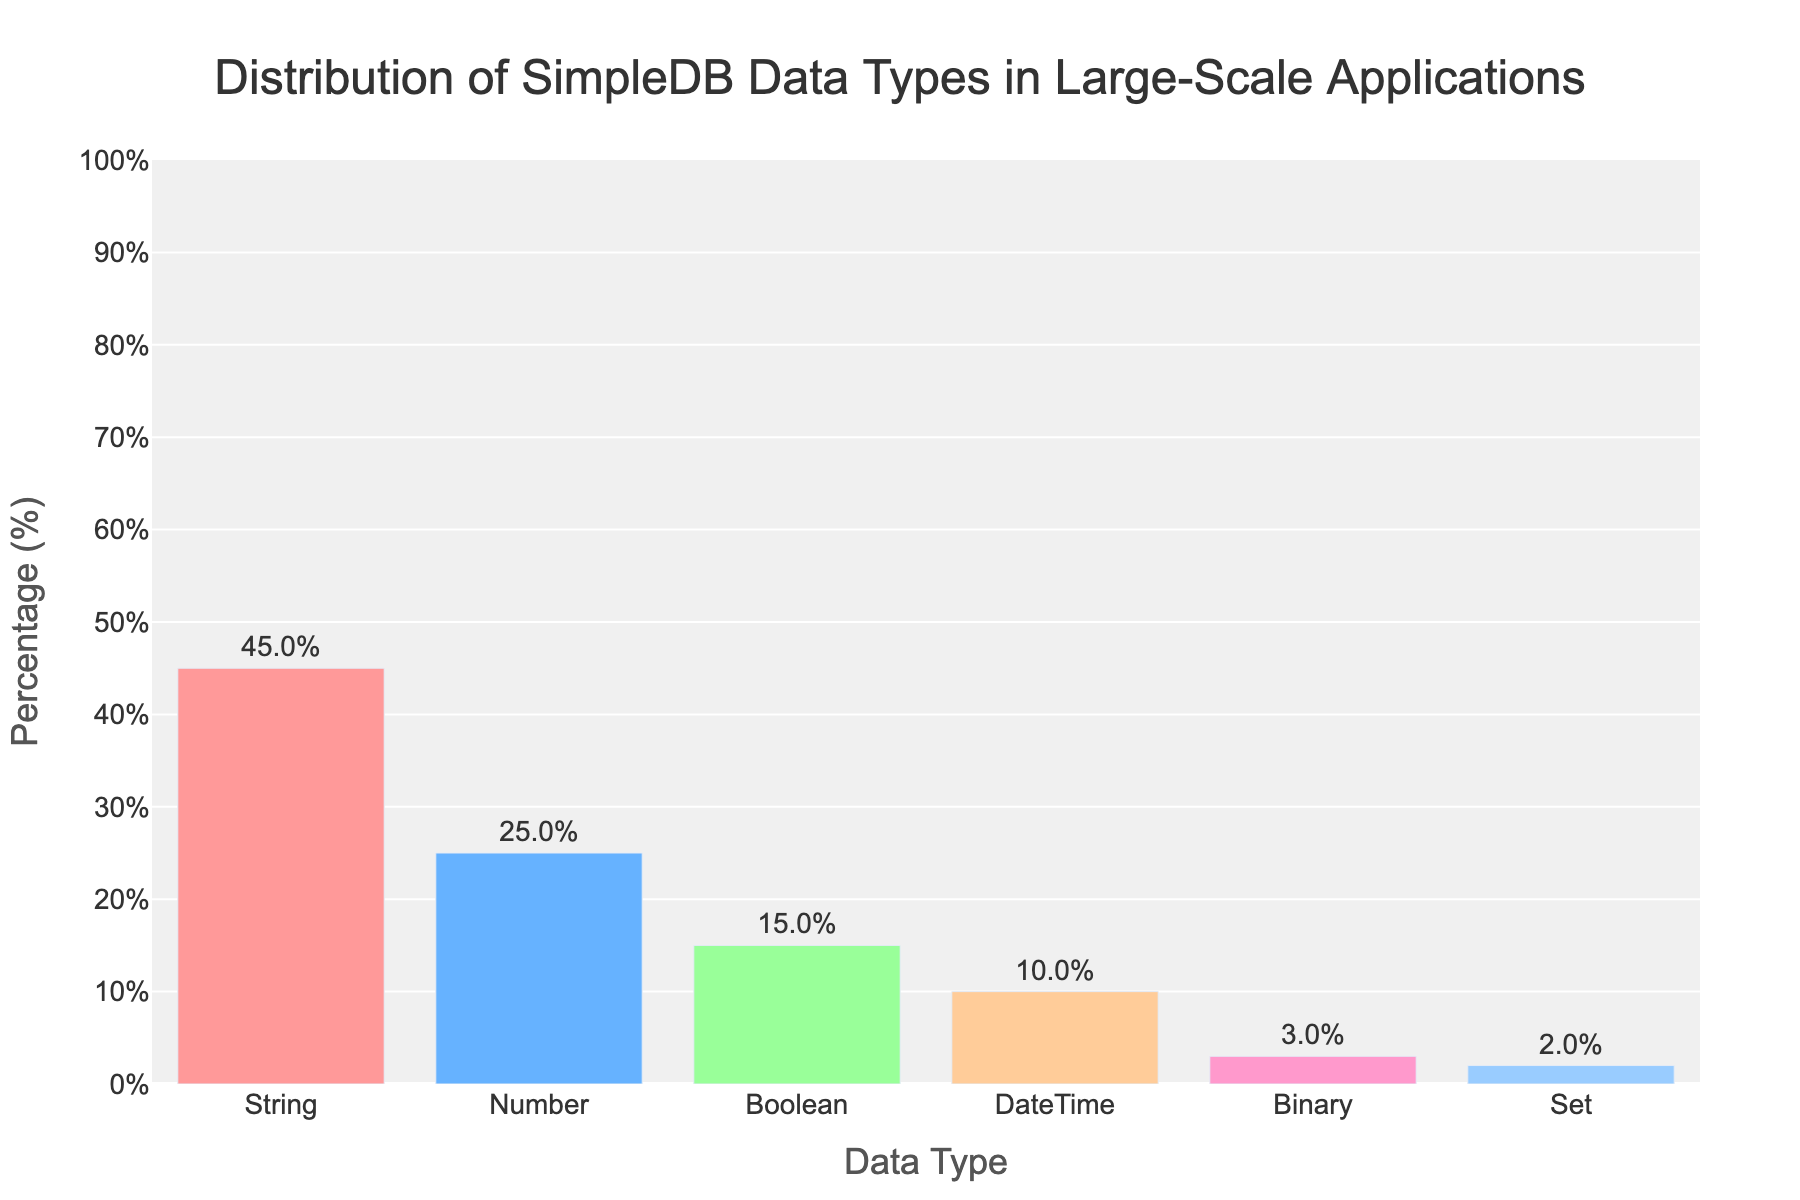Which data type has the highest percentage in the distribution? By observing the bar chart, the data type with the tallest bar represents the largest percentage. The bar associated with "String" is the tallest, showing the highest percentage.
Answer: String How much higher is the percentage of the "Number" data type compared to the "Binary" data type? The heights of the bars indicate the percentages. The "Number" data type has a percentage of 25%, and the "Binary" data type has 3%. The difference is 25% - 3%.
Answer: 22% What is the combined percentage of the "Boolean" and "DateTime" data types? The corresponding bars for "Boolean" and "DateTime" indicate 15% and 10%, respectively. Adding these together gives 15% + 10%.
Answer: 25% Which data type has the smallest percentage, and what is that percentage? The shortest bar in the chart corresponds to the "Set" data type, indicating it has the smallest percentage. The percentage shown is 2%.
Answer: Set, 2% How does the percentage of "String" compare to the total percentage of "Boolean" and "DateTime" combined? The "String" data type has a percentage of 45%, while the sum of "Boolean" (15%) and "DateTime" (10%) is 25%. The "String" percentage is higher by 45% - 25%.
Answer: 20% higher What is the percentage difference between the most and least common data types? The "String" data type represents the highest percentage (45%), and the "Set" data type represents the lowest (2%). The difference is 45% - 2%.
Answer: 43% What fraction of the data types are used less than 10% of the time? The data types with percentages less than 10% are "Binary" (3%) and "Set" (2%). Out of six total data types, there are 2 such data types, so the fraction is 2/6.
Answer: 1/3 What is the total percentage for all data types except "String"? By adding the percentages of "Number" (25%), "Boolean" (15%), "DateTime" (10%), "Binary" (3%), and "Set" (2%), we find the total excluding "String".
Answer: 55% What are the colors used for the bars representing the "Boolean" and "Set" data types? The bar representing "Boolean" is green, and the bar representing "Set" is also a shade of blue. The choice of colors is easily visible in the chart.
Answer: Green and blue 